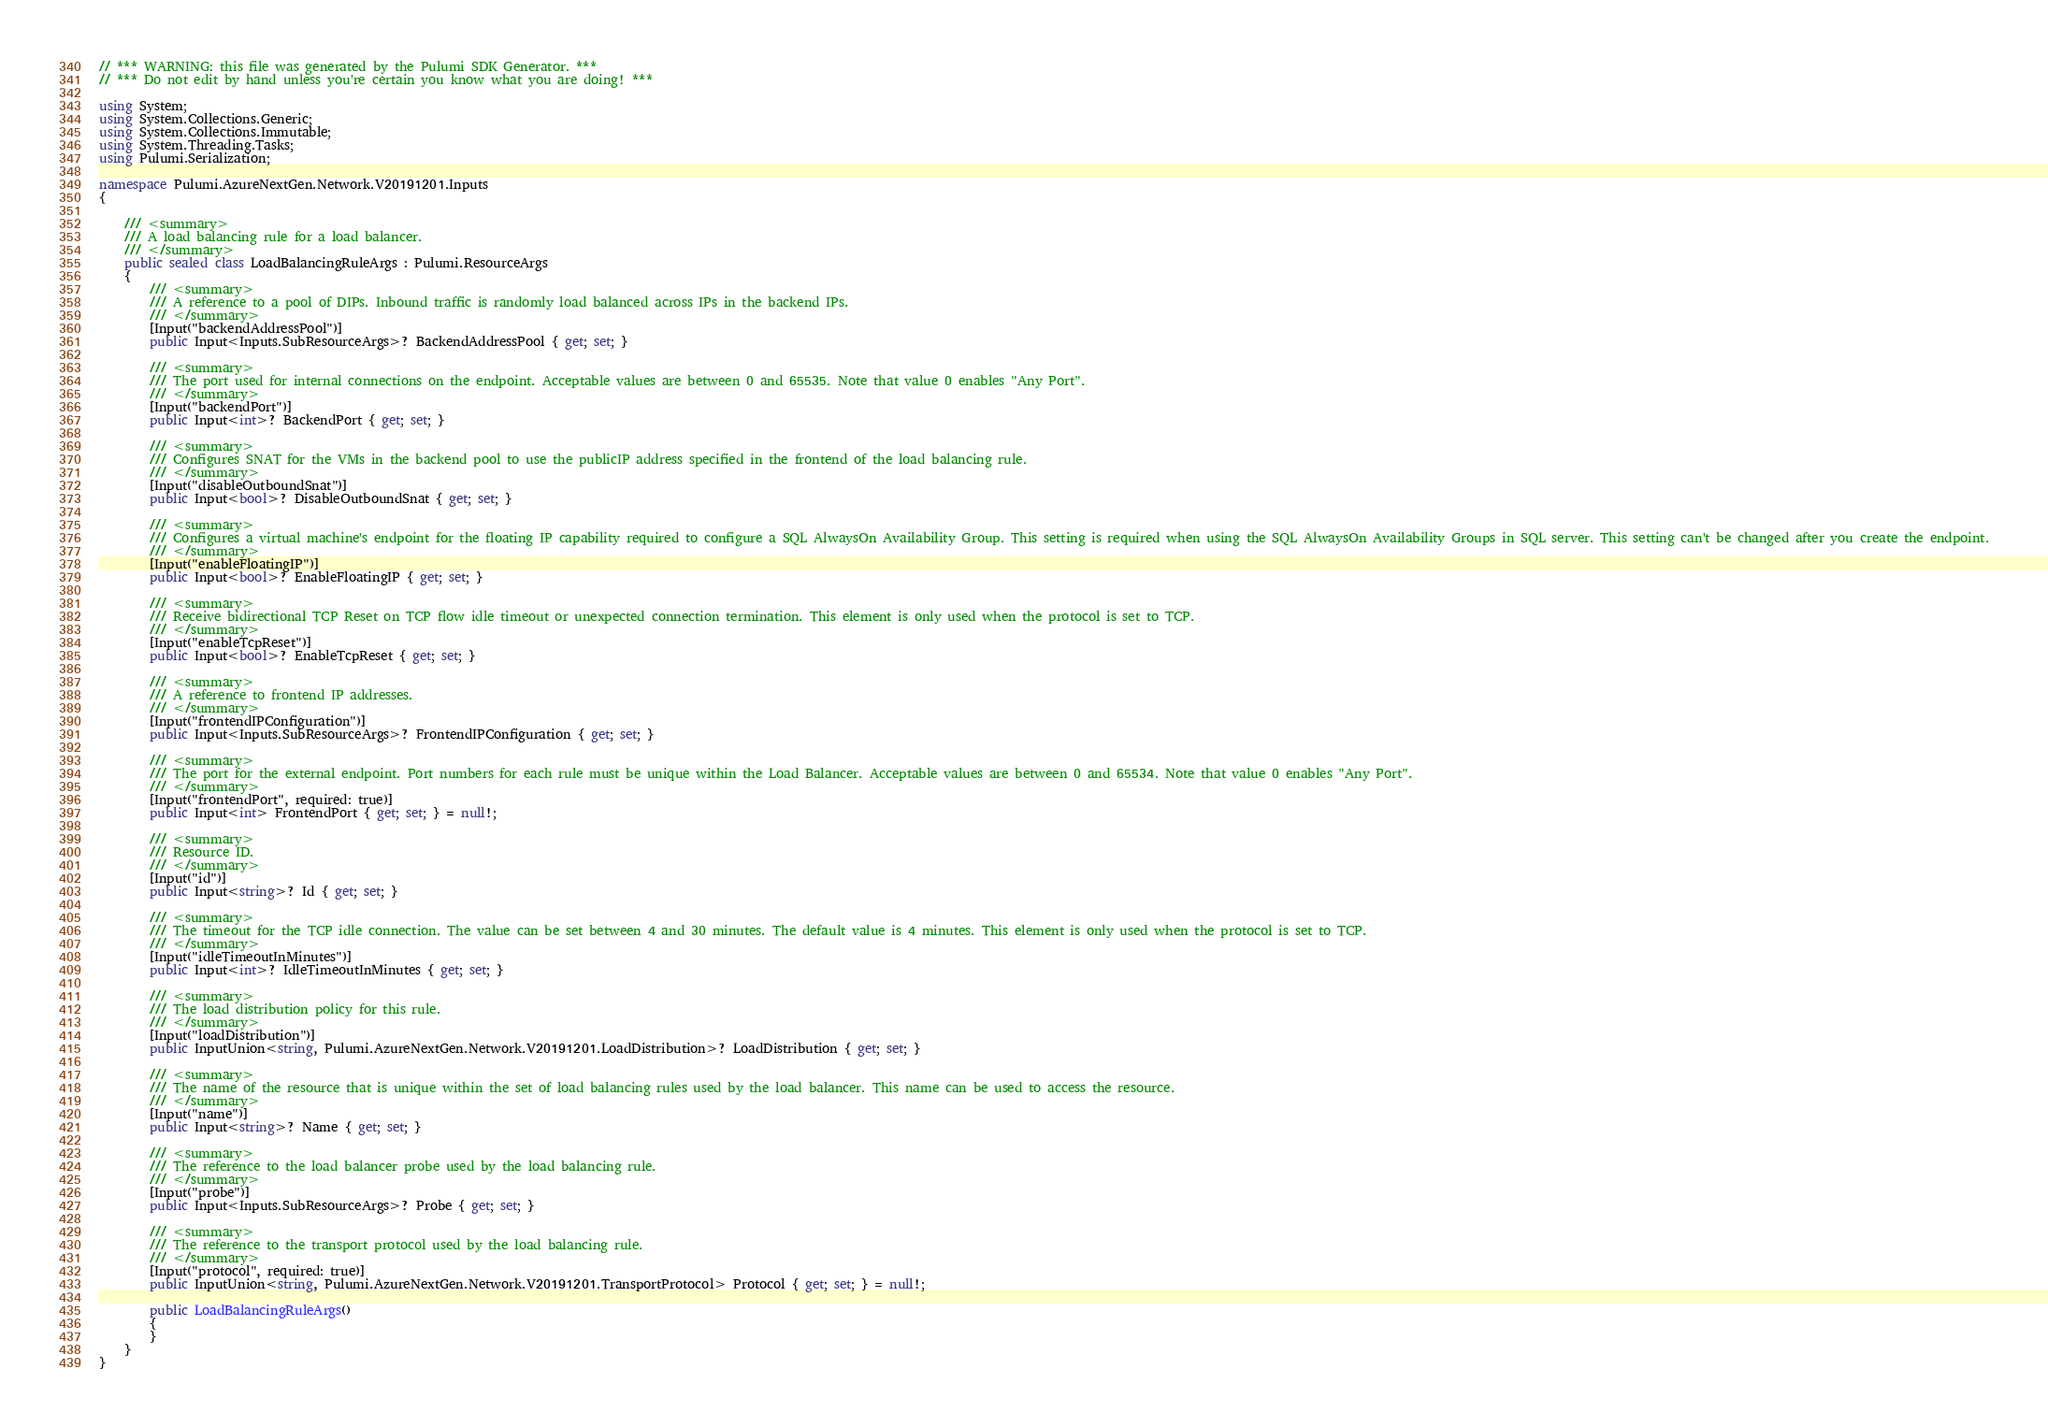<code> <loc_0><loc_0><loc_500><loc_500><_C#_>// *** WARNING: this file was generated by the Pulumi SDK Generator. ***
// *** Do not edit by hand unless you're certain you know what you are doing! ***

using System;
using System.Collections.Generic;
using System.Collections.Immutable;
using System.Threading.Tasks;
using Pulumi.Serialization;

namespace Pulumi.AzureNextGen.Network.V20191201.Inputs
{

    /// <summary>
    /// A load balancing rule for a load balancer.
    /// </summary>
    public sealed class LoadBalancingRuleArgs : Pulumi.ResourceArgs
    {
        /// <summary>
        /// A reference to a pool of DIPs. Inbound traffic is randomly load balanced across IPs in the backend IPs.
        /// </summary>
        [Input("backendAddressPool")]
        public Input<Inputs.SubResourceArgs>? BackendAddressPool { get; set; }

        /// <summary>
        /// The port used for internal connections on the endpoint. Acceptable values are between 0 and 65535. Note that value 0 enables "Any Port".
        /// </summary>
        [Input("backendPort")]
        public Input<int>? BackendPort { get; set; }

        /// <summary>
        /// Configures SNAT for the VMs in the backend pool to use the publicIP address specified in the frontend of the load balancing rule.
        /// </summary>
        [Input("disableOutboundSnat")]
        public Input<bool>? DisableOutboundSnat { get; set; }

        /// <summary>
        /// Configures a virtual machine's endpoint for the floating IP capability required to configure a SQL AlwaysOn Availability Group. This setting is required when using the SQL AlwaysOn Availability Groups in SQL server. This setting can't be changed after you create the endpoint.
        /// </summary>
        [Input("enableFloatingIP")]
        public Input<bool>? EnableFloatingIP { get; set; }

        /// <summary>
        /// Receive bidirectional TCP Reset on TCP flow idle timeout or unexpected connection termination. This element is only used when the protocol is set to TCP.
        /// </summary>
        [Input("enableTcpReset")]
        public Input<bool>? EnableTcpReset { get; set; }

        /// <summary>
        /// A reference to frontend IP addresses.
        /// </summary>
        [Input("frontendIPConfiguration")]
        public Input<Inputs.SubResourceArgs>? FrontendIPConfiguration { get; set; }

        /// <summary>
        /// The port for the external endpoint. Port numbers for each rule must be unique within the Load Balancer. Acceptable values are between 0 and 65534. Note that value 0 enables "Any Port".
        /// </summary>
        [Input("frontendPort", required: true)]
        public Input<int> FrontendPort { get; set; } = null!;

        /// <summary>
        /// Resource ID.
        /// </summary>
        [Input("id")]
        public Input<string>? Id { get; set; }

        /// <summary>
        /// The timeout for the TCP idle connection. The value can be set between 4 and 30 minutes. The default value is 4 minutes. This element is only used when the protocol is set to TCP.
        /// </summary>
        [Input("idleTimeoutInMinutes")]
        public Input<int>? IdleTimeoutInMinutes { get; set; }

        /// <summary>
        /// The load distribution policy for this rule.
        /// </summary>
        [Input("loadDistribution")]
        public InputUnion<string, Pulumi.AzureNextGen.Network.V20191201.LoadDistribution>? LoadDistribution { get; set; }

        /// <summary>
        /// The name of the resource that is unique within the set of load balancing rules used by the load balancer. This name can be used to access the resource.
        /// </summary>
        [Input("name")]
        public Input<string>? Name { get; set; }

        /// <summary>
        /// The reference to the load balancer probe used by the load balancing rule.
        /// </summary>
        [Input("probe")]
        public Input<Inputs.SubResourceArgs>? Probe { get; set; }

        /// <summary>
        /// The reference to the transport protocol used by the load balancing rule.
        /// </summary>
        [Input("protocol", required: true)]
        public InputUnion<string, Pulumi.AzureNextGen.Network.V20191201.TransportProtocol> Protocol { get; set; } = null!;

        public LoadBalancingRuleArgs()
        {
        }
    }
}
</code> 